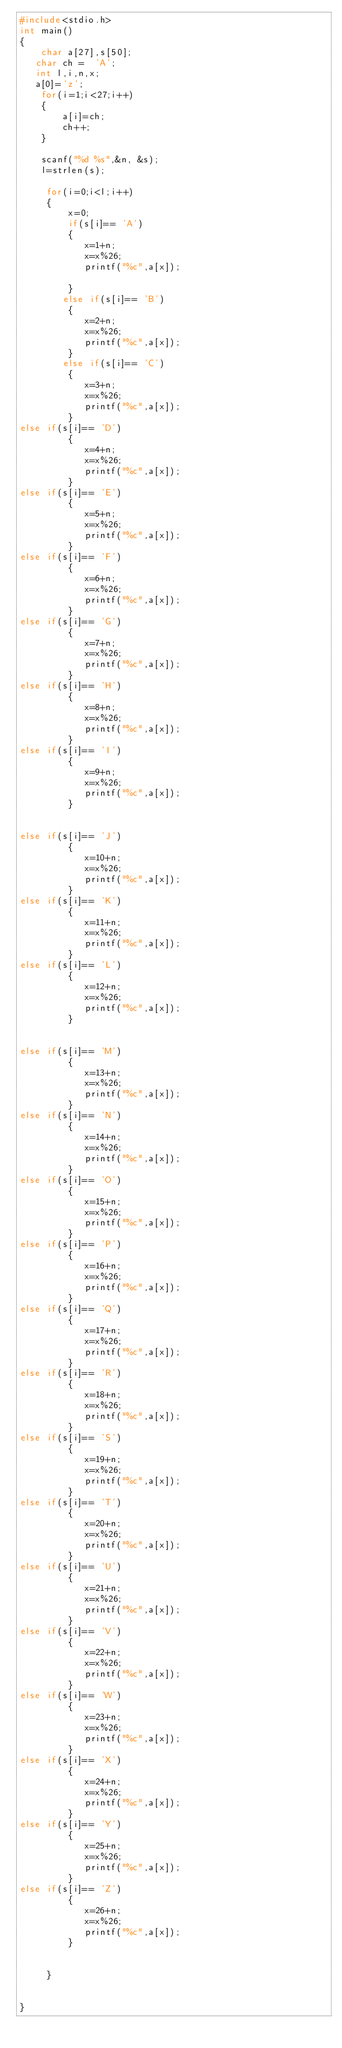Convert code to text. <code><loc_0><loc_0><loc_500><loc_500><_C_>#include<stdio.h>
int main()
{
    char a[27],s[50];
   char ch =  'A';
   int l,i,n,x;
   a[0]='z';
    for(i=1;i<27;i++)
    {
        a[i]=ch;
        ch++;
    }

    scanf("%d %s",&n, &s);
    l=strlen(s);

     for(i=0;i<l;i++)
     {
         x=0;
         if(s[i]== 'A')
         {
            x=1+n;
            x=x%26;
            printf("%c",a[x]);

         }
        else if(s[i]== 'B')
         {
            x=2+n;
            x=x%26;
            printf("%c",a[x]);
         }
        else if(s[i]== 'C')
         {
            x=3+n;
            x=x%26;
            printf("%c",a[x]);
         }
else if(s[i]== 'D')
         {
            x=4+n;
            x=x%26;
            printf("%c",a[x]);
         }
else if(s[i]== 'E')
         {
            x=5+n;
            x=x%26;
            printf("%c",a[x]);
         }
else if(s[i]== 'F')
         {
            x=6+n;
            x=x%26;
            printf("%c",a[x]);
         }
else if(s[i]== 'G')
         {
            x=7+n;
            x=x%26;
            printf("%c",a[x]);
         }
else if(s[i]== 'H')
         {
            x=8+n;
            x=x%26;
            printf("%c",a[x]);
         }
else if(s[i]== 'I')
         {
            x=9+n;
            x=x%26;
            printf("%c",a[x]);
         }


else if(s[i]== 'J')
         {
            x=10+n;
            x=x%26;
            printf("%c",a[x]);
         }
else if(s[i]== 'K')
         {
            x=11+n;
            x=x%26;
            printf("%c",a[x]);
         }
else if(s[i]== 'L')
         {
            x=12+n;
            x=x%26;
            printf("%c",a[x]);
         }


else if(s[i]== 'M')
         {
            x=13+n;
            x=x%26;
            printf("%c",a[x]);
         }
else if(s[i]== 'N')
         {
            x=14+n;
            x=x%26;
            printf("%c",a[x]);
         }
else if(s[i]== 'O')
         {
            x=15+n;
            x=x%26;
            printf("%c",a[x]);
         }
else if(s[i]== 'P')
         {
            x=16+n;
            x=x%26;
            printf("%c",a[x]);
         }
else if(s[i]== 'Q')
         {
            x=17+n;
            x=x%26;
            printf("%c",a[x]);
         }
else if(s[i]== 'R')
         {
            x=18+n;
            x=x%26;
            printf("%c",a[x]);
         }
else if(s[i]== 'S')
         {
            x=19+n;
            x=x%26;
            printf("%c",a[x]);
         }
else if(s[i]== 'T')
         {
            x=20+n;
            x=x%26;
            printf("%c",a[x]);
         }
else if(s[i]== 'U')
         {
            x=21+n;
            x=x%26;
            printf("%c",a[x]);
         }
else if(s[i]== 'V')
         {
            x=22+n;
            x=x%26;
            printf("%c",a[x]);
         }
else if(s[i]== 'W')
         {
            x=23+n;
            x=x%26;
            printf("%c",a[x]);
         }
else if(s[i]== 'X')
         {
            x=24+n;
            x=x%26;
            printf("%c",a[x]);
         }
else if(s[i]== 'Y')
         {
            x=25+n;
            x=x%26;
            printf("%c",a[x]);
         }
else if(s[i]== 'Z')
         {
            x=26+n;
            x=x%26;
            printf("%c",a[x]);
         }


     }


}
</code> 